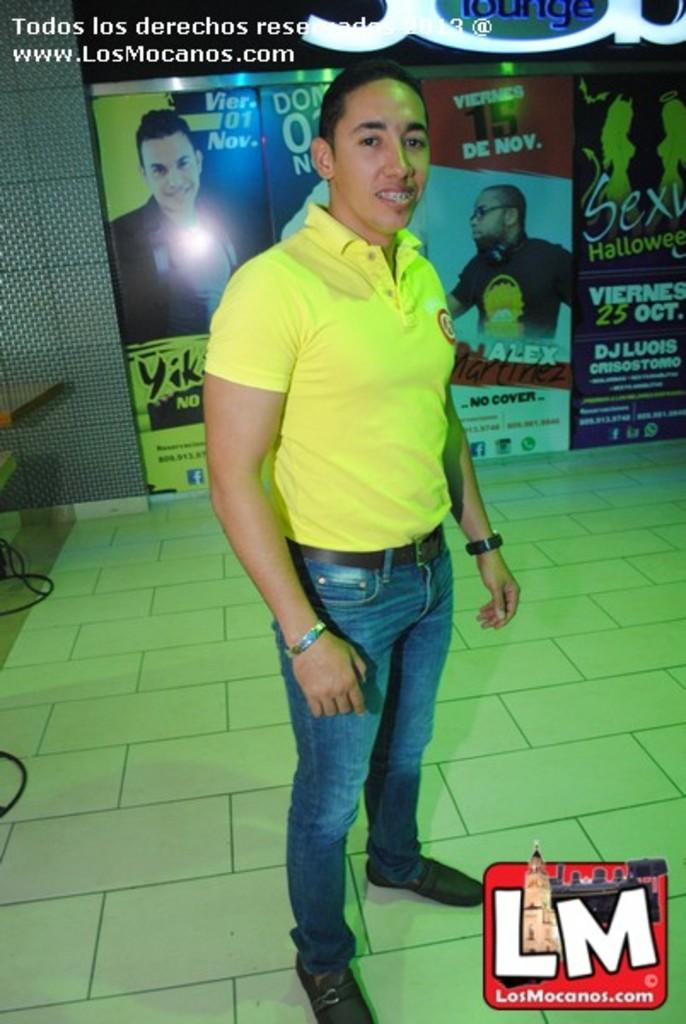What is the main subject of the image? There is a man standing in the image. Where is the man standing? The man is standing on the floor. What else can be seen in the image besides the man? There are wires, a table, a wall, and a board with pictures and text visible in the image. Can you see the moon in the image? No, the moon is not present in the image. Are there any bubbles visible in the image? No, there are no bubbles visible in the image. 